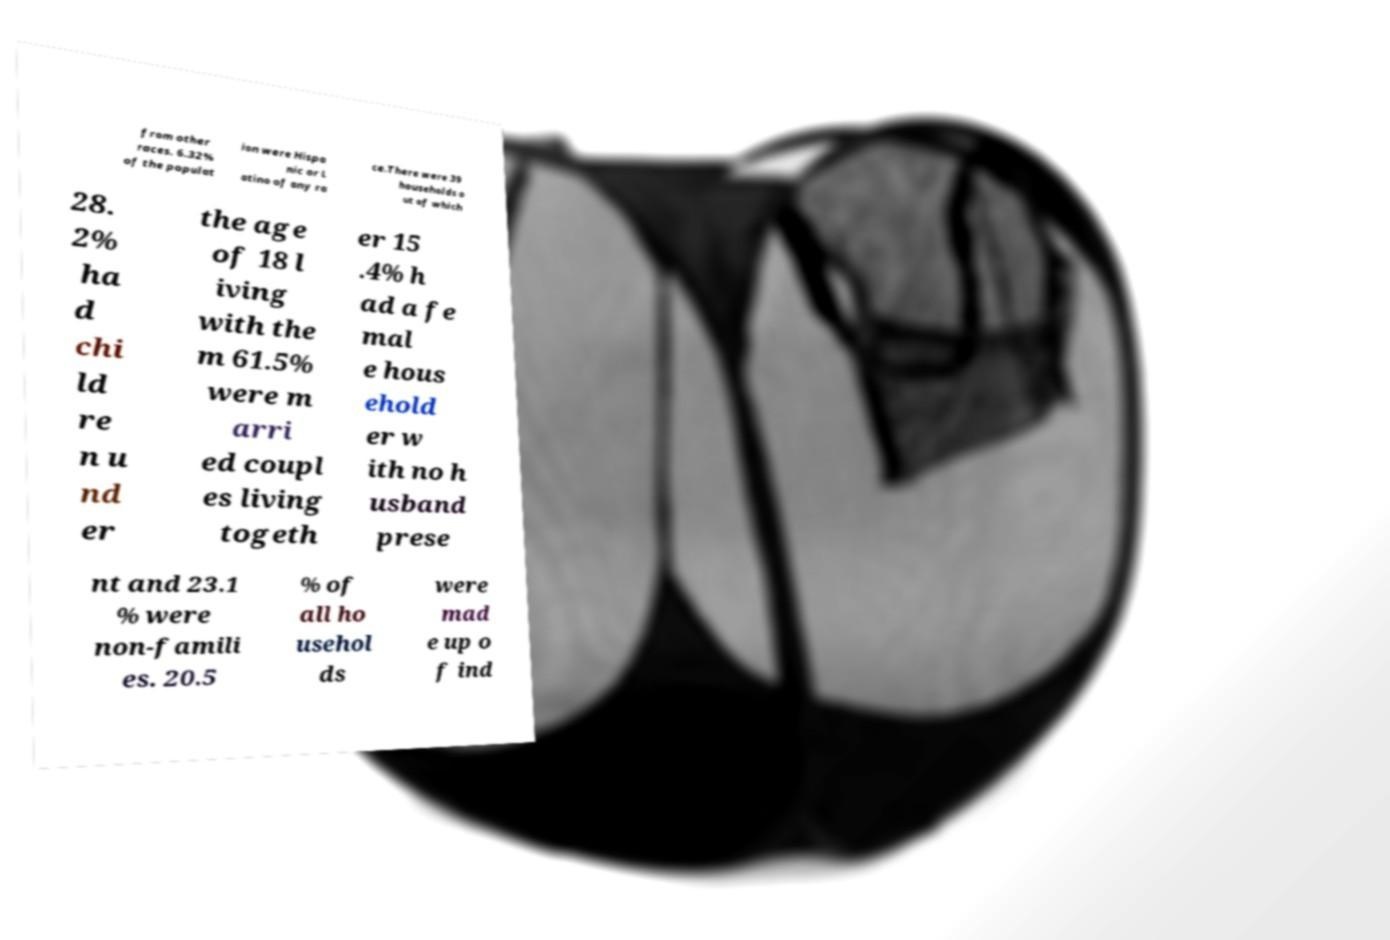Can you accurately transcribe the text from the provided image for me? from other races. 6.32% of the populat ion were Hispa nic or L atino of any ra ce.There were 39 households o ut of which 28. 2% ha d chi ld re n u nd er the age of 18 l iving with the m 61.5% were m arri ed coupl es living togeth er 15 .4% h ad a fe mal e hous ehold er w ith no h usband prese nt and 23.1 % were non-famili es. 20.5 % of all ho usehol ds were mad e up o f ind 